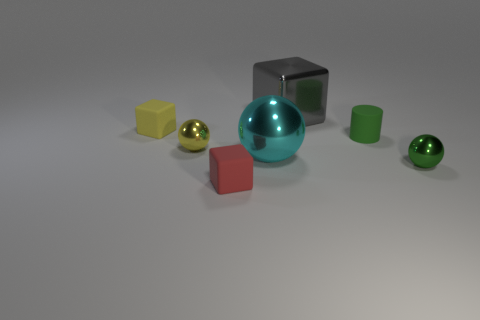Add 1 yellow metallic spheres. How many objects exist? 8 Subtract all blocks. How many objects are left? 4 Add 7 cyan metal spheres. How many cyan metal spheres are left? 8 Add 6 cyan balls. How many cyan balls exist? 7 Subtract 0 cyan cylinders. How many objects are left? 7 Subtract all large metallic blocks. Subtract all small green metal things. How many objects are left? 5 